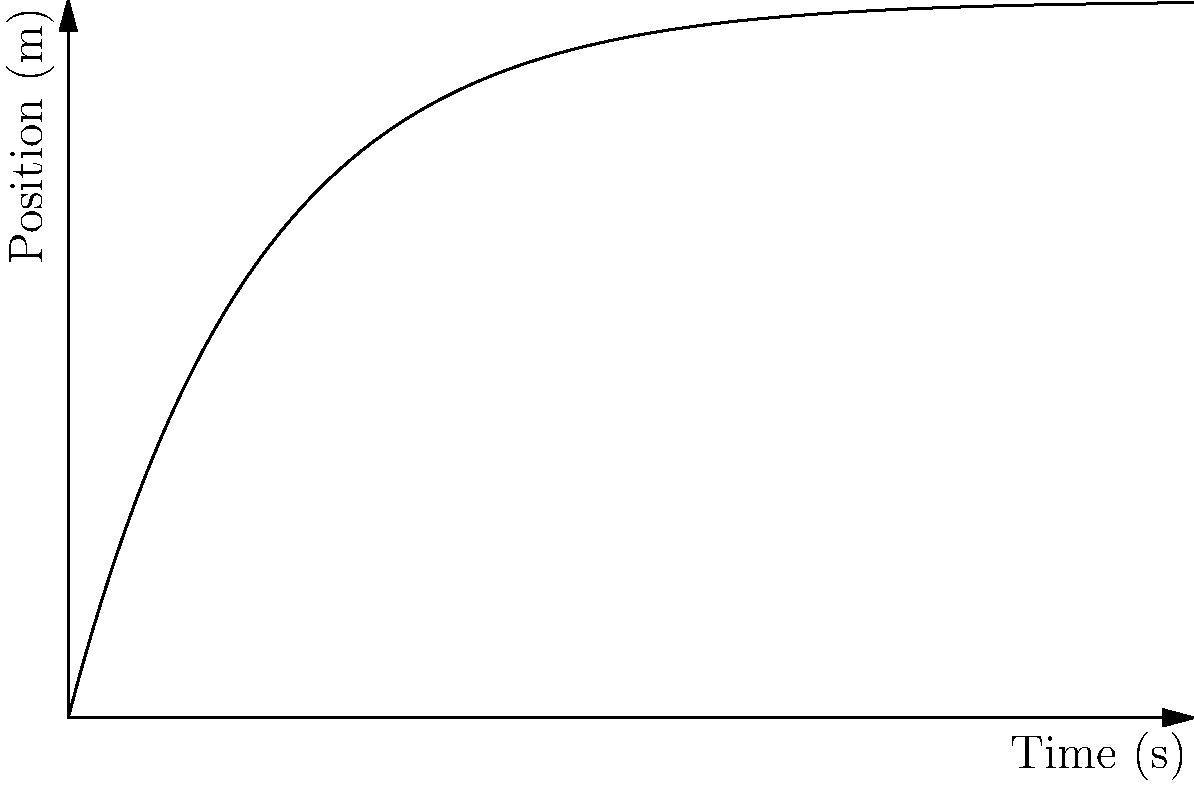Given the position vs. time graph of a Formula 1 car during a lap, determine the velocity of the car at t = 30 seconds. To find the velocity at t = 30 seconds, we need to calculate the derivative of the position function at that point. Here's how we can do it:

1. The position function appears to be of the form:
   $$s(t) = 3000(1 - e^{-0.1t})$$

2. To find velocity, we need to differentiate s(t) with respect to t:
   $$v(t) = \frac{d}{dt}[3000(1 - e^{-0.1t})]$$
   $$v(t) = 3000 \cdot 0.1 \cdot e^{-0.1t}$$
   $$v(t) = 300e^{-0.1t}$$

3. Now, we can calculate the velocity at t = 30 seconds:
   $$v(30) = 300e^{-0.1(30)}$$
   $$v(30) = 300e^{-3}$$
   $$v(30) \approx 49.79 \text{ m/s}$$

4. Converting to km/h:
   $$49.79 \text{ m/s} \cdot \frac{3600 \text{ s}}{1 \text{ h}} \cdot \frac{1 \text{ km}}{1000 \text{ m}} \approx 179.24 \text{ km/h}$$

Therefore, the velocity of the Formula 1 car at t = 30 seconds is approximately 179.24 km/h.
Answer: 179.24 km/h 